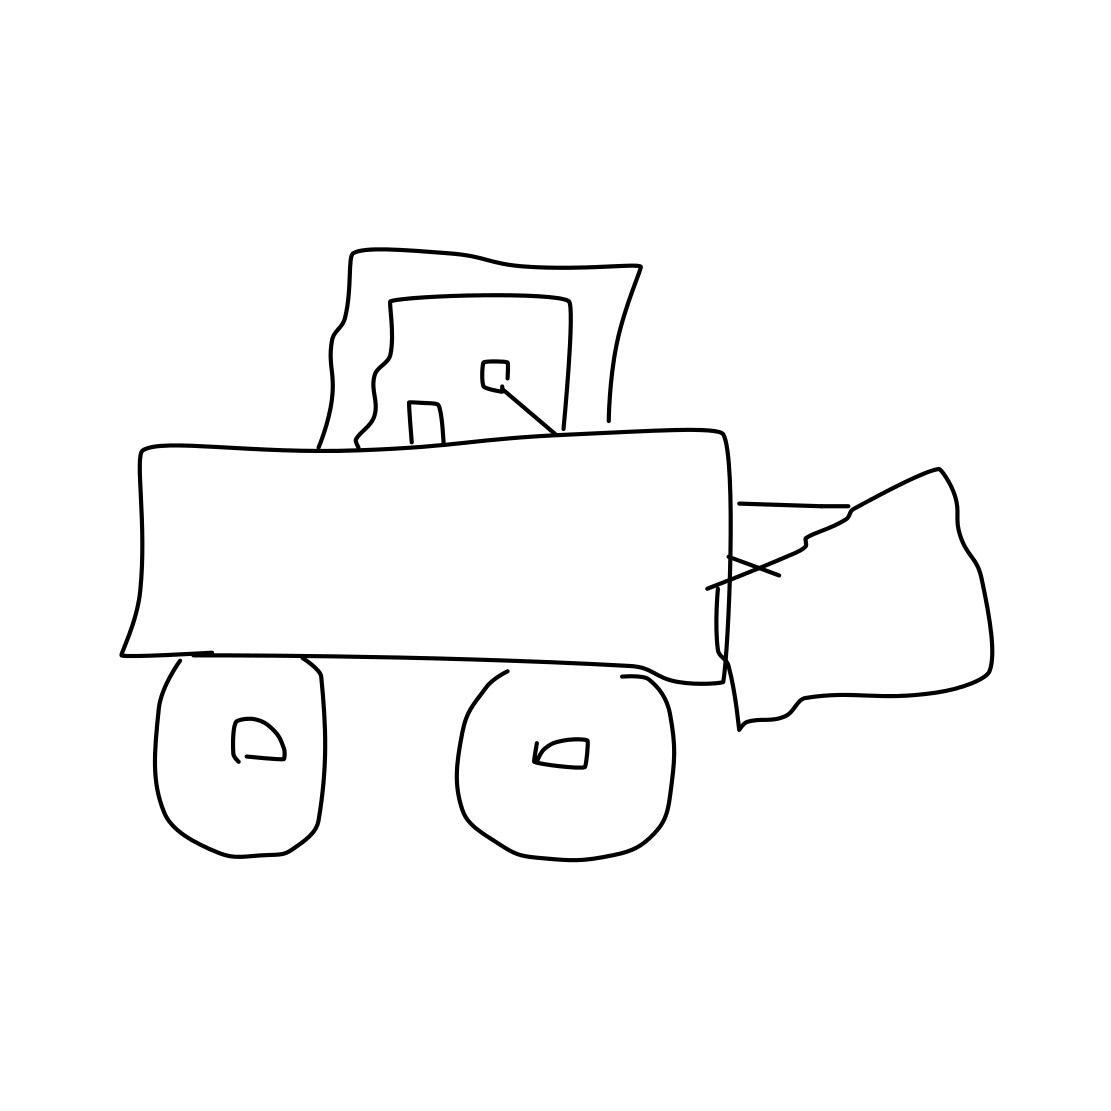What could be the purpose of the frontal blade on this bulldozer? The frontal blade on a bulldozer is typically used for pushing large quantities of soil, sand, rubble, or other similar materials during construction or excavation tasks. Does it look functional in its current state? The blade appears to have a crack or break on its right side, which might hinder its functionality. It would likely require repair to be fully operational again. 